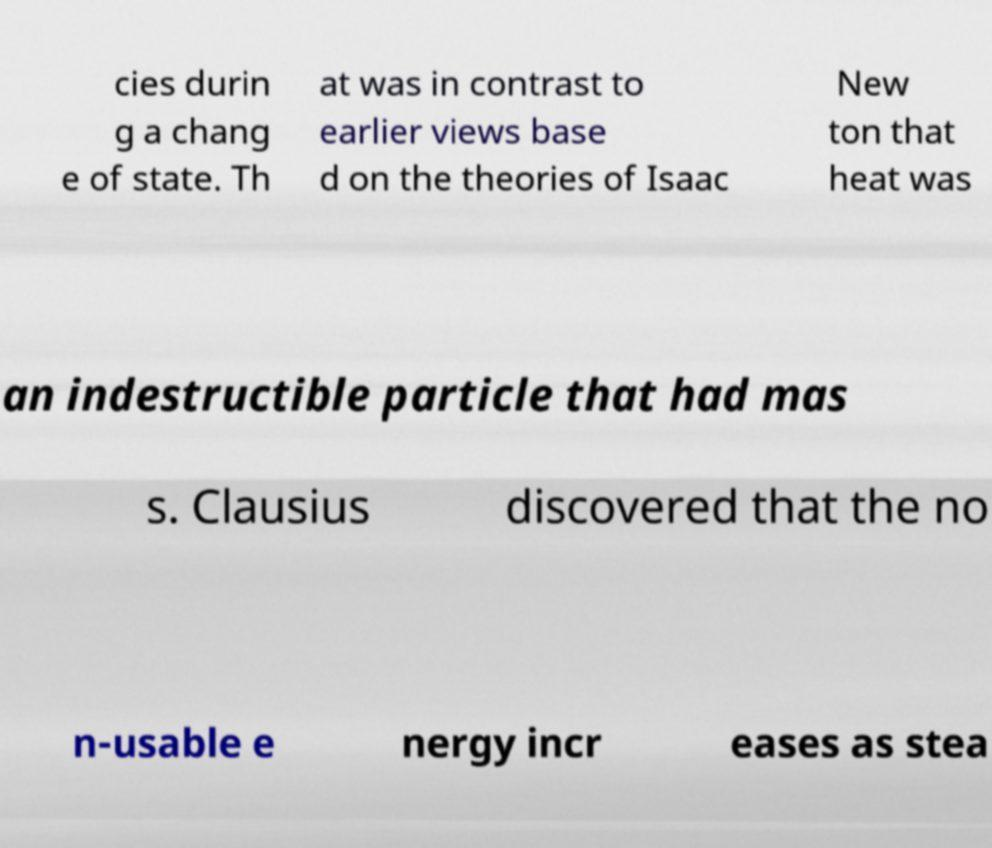Please identify and transcribe the text found in this image. cies durin g a chang e of state. Th at was in contrast to earlier views base d on the theories of Isaac New ton that heat was an indestructible particle that had mas s. Clausius discovered that the no n-usable e nergy incr eases as stea 